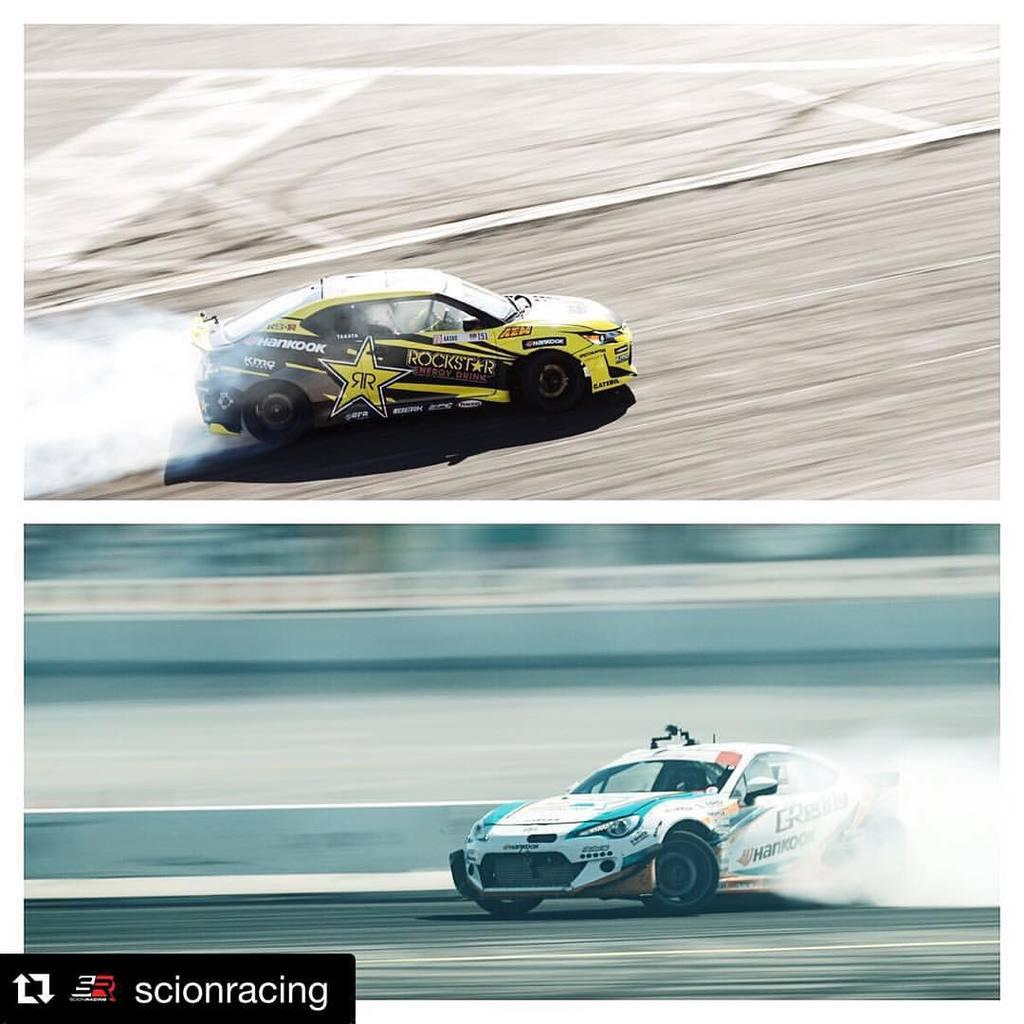What is the main subject of the image? The main subject of the image is racing cars. What are the racing cars doing in the image? The racing cars are moving on the road in the image. Is there any text present in the image? Yes, there is some text written at the bottom left of the image. Can you see a giraffe in the image? No, there is no giraffe present in the image. What is the aftermath of the race in the image? The image does not show the aftermath of the race; it only shows the racing cars moving on the road. 